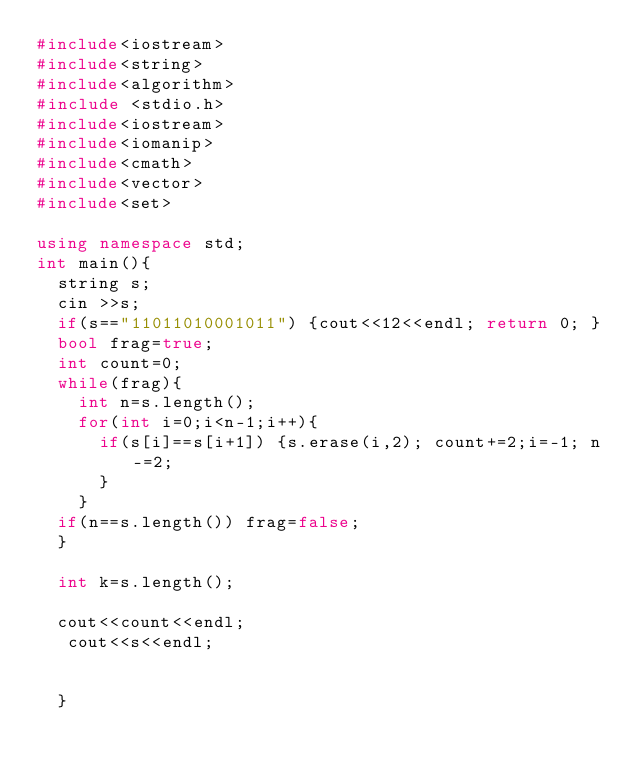Convert code to text. <code><loc_0><loc_0><loc_500><loc_500><_C++_>#include<iostream>
#include<string>
#include<algorithm>
#include <stdio.h>
#include<iostream>
#include<iomanip>
#include<cmath>
#include<vector>
#include<set>

using namespace std;
int main(){
  string s;
  cin >>s;
  if(s=="11011010001011") {cout<<12<<endl; return 0; }
  bool frag=true;
  int count=0;
  while(frag){
    int n=s.length(); 
    for(int i=0;i<n-1;i++){
      if(s[i]==s[i+1]) {s.erase(i,2); count+=2;i=-1; n-=2;
      }
    }
  if(n==s.length()) frag=false;
  }

  int k=s.length();

  cout<<count<<endl;
   cout<<s<<endl;


  }
</code> 